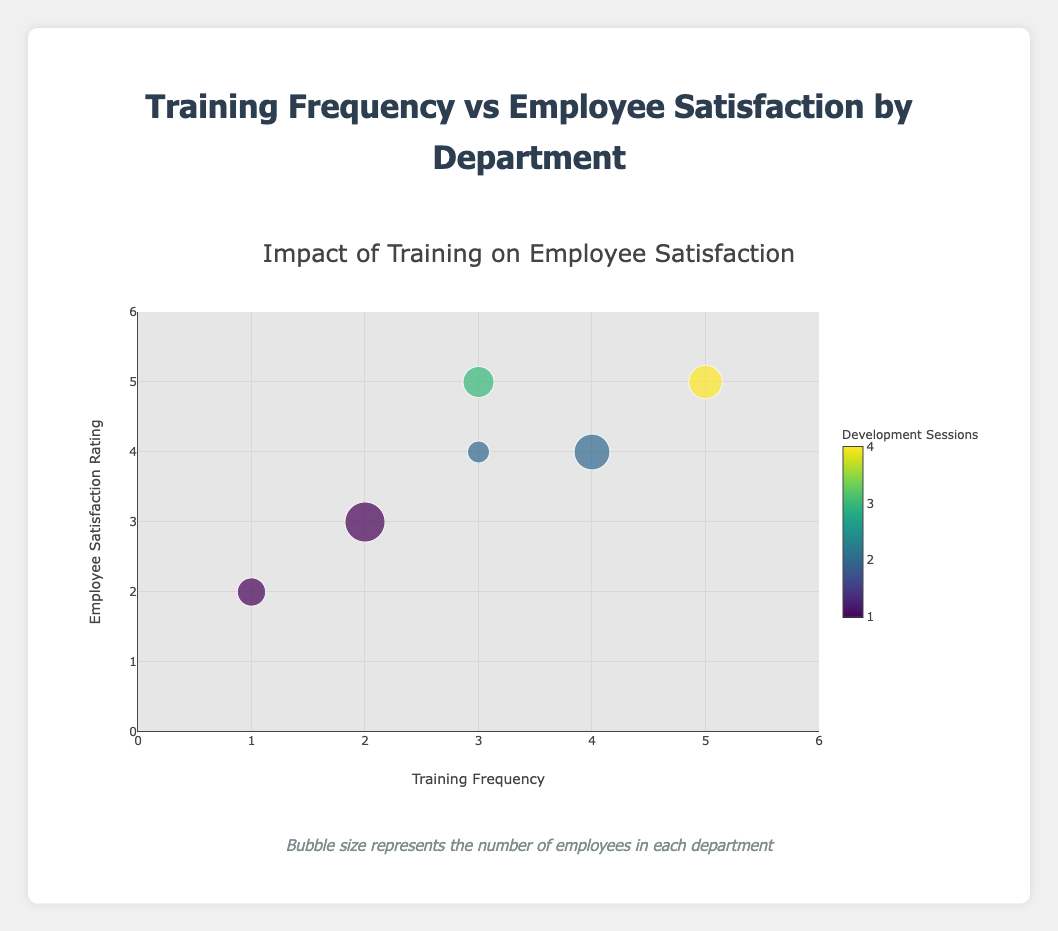Which department has the highest Employee Satisfaction Rating? By looking at the y-axis and the position of the points, the highest Employee Satisfaction Rating is 5. The departments that rank 5 on satisfaction are Technical Support and Operations.
Answer: Technical Support and Operations What's the average Training Frequency across all departments? To calculate the average, sum up all the Training Frequencies and divide by the number of departments. (2 + 4 + 3 + 1 + 3 + 5) / 6 = 18 / 6 = 3
Answer: 3 Which department has the most employees? By looking at the size of the bubbles which represents Employee Count, the largest bubble corresponds to the Customer Service department with 50 employees.
Answer: Customer Service Which department holds the highest Development Sessions? By observing the legend, color gradient, and the text information on hover, it's clear that the Operations department has the highest Development Sessions value of 4.
Answer: Operations How does the Employee Satisfaction Rating of Marketing compare to that of Sales? Marketing has an Employee Satisfaction Rating of 2, while Sales has a rating of 4. Therefore, Sales has a higher rating than Marketing.
Answer: Sales has a higher rating Is there a visible correlation between Training Frequency and Employee Satisfaction Rating? Analyzing the plot, it seems that departments with higher Training Frequency tend to also have higher Employee Satisfaction Ratings, indicating a positive correlation.
Answer: Positive correlation Which department shows the least frequency in Training and Development Sessions? According to the values shown, Marketing has the least Training Frequency (1) and the least Development Sessions (1).
Answer: Marketing How many departments have an Employee Satisfaction Rating of 4? Observing the y-axis and points, Sales and Human Resources both have an Employee Satisfaction Rating of 4, making it a total of 2 departments.
Answer: 2 departments What's the total number of employees represented in the chart? Adding the Employee Counts across all departments (50 + 40 + 30 + 25 + 15 + 35) yields a total of 195 employees.
Answer: 195 